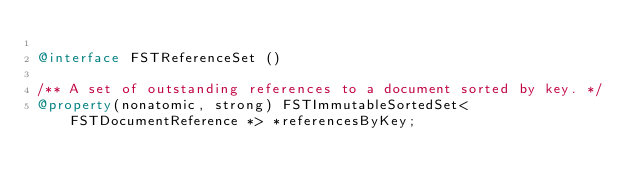Convert code to text. <code><loc_0><loc_0><loc_500><loc_500><_ObjectiveC_>
@interface FSTReferenceSet ()

/** A set of outstanding references to a document sorted by key. */
@property(nonatomic, strong) FSTImmutableSortedSet<FSTDocumentReference *> *referencesByKey;
</code> 